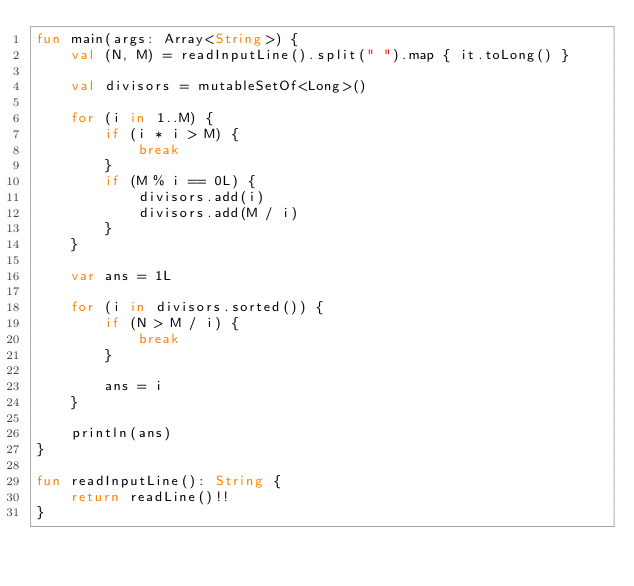Convert code to text. <code><loc_0><loc_0><loc_500><loc_500><_Kotlin_>fun main(args: Array<String>) {
    val (N, M) = readInputLine().split(" ").map { it.toLong() }
    
    val divisors = mutableSetOf<Long>()
    
    for (i in 1..M) {
        if (i * i > M) {
            break
        }
        if (M % i == 0L) {
            divisors.add(i)
            divisors.add(M / i)
        }
    }
    
    var ans = 1L
    
    for (i in divisors.sorted()) {
        if (N > M / i) {
            break
        }
        
        ans = i
    }
    
    println(ans)
}

fun readInputLine(): String {
    return readLine()!!
}
</code> 